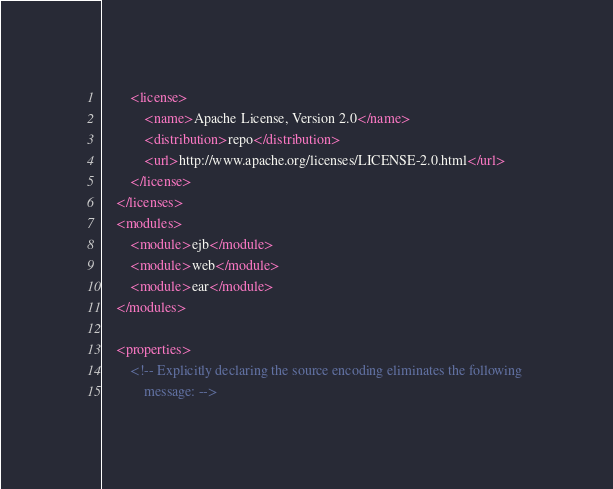Convert code to text. <code><loc_0><loc_0><loc_500><loc_500><_XML_>        <license>
            <name>Apache License, Version 2.0</name>
            <distribution>repo</distribution>
            <url>http://www.apache.org/licenses/LICENSE-2.0.html</url>
        </license>
    </licenses>
    <modules>
        <module>ejb</module>
        <module>web</module>
        <module>ear</module>
    </modules>

    <properties>
        <!-- Explicitly declaring the source encoding eliminates the following 
            message: --></code> 